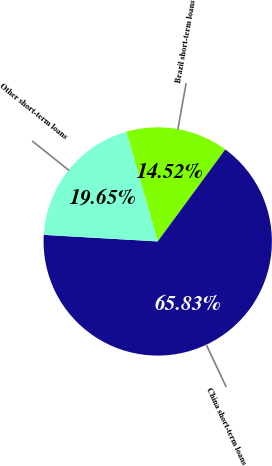Convert chart to OTSL. <chart><loc_0><loc_0><loc_500><loc_500><pie_chart><fcel>Brazil short-term loans<fcel>China short-term loans<fcel>Other short-term loans<nl><fcel>14.52%<fcel>65.83%<fcel>19.65%<nl></chart> 